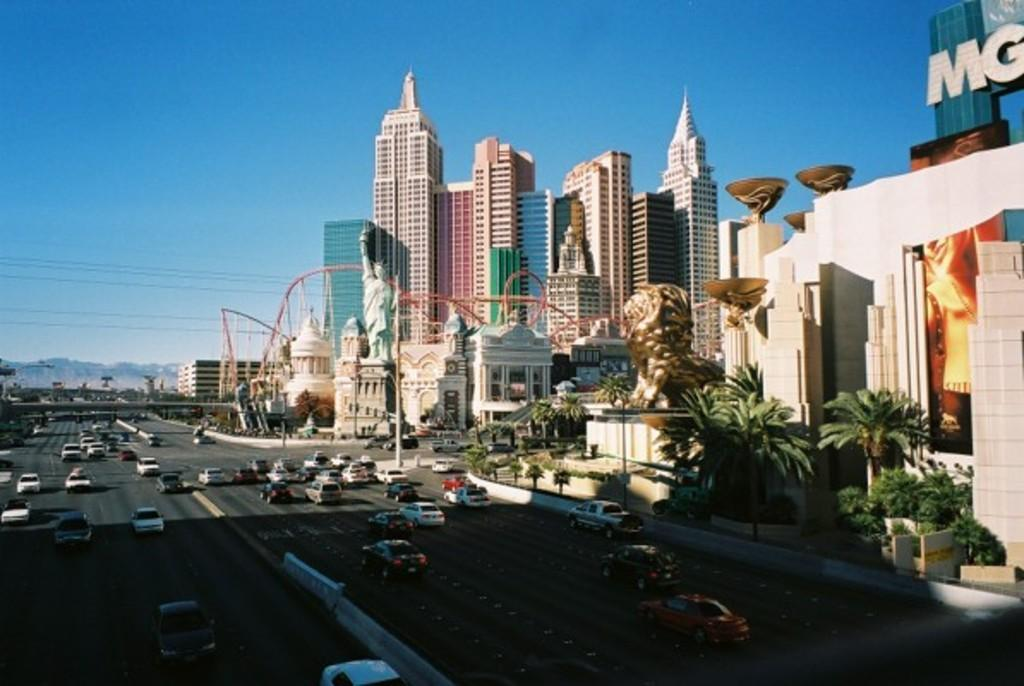What can be seen on the road in the image? There are cars on the road in the image. What is located on the right side of the image? There are trees, sculptures, and buildings on the right side of the image. What is visible in the background of the image? There are mountains visible in the background of the image. What type of pen is being used to draw the mountains in the image? There is no pen present in the image, and the mountains are not being drawn. They are a natural part of the landscape visible in the background. 